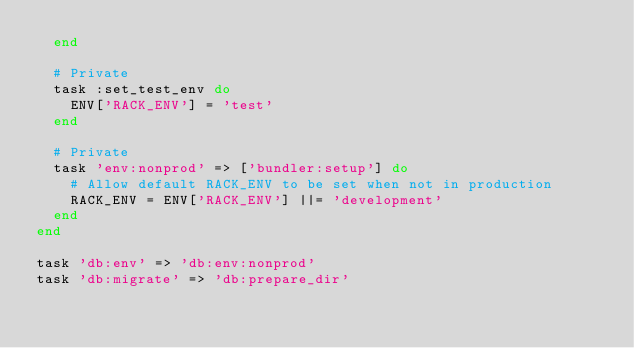<code> <loc_0><loc_0><loc_500><loc_500><_Ruby_>  end

  # Private
  task :set_test_env do
    ENV['RACK_ENV'] = 'test'
  end

  # Private
  task 'env:nonprod' => ['bundler:setup'] do
    # Allow default RACK_ENV to be set when not in production
    RACK_ENV = ENV['RACK_ENV'] ||= 'development'
  end
end

task 'db:env' => 'db:env:nonprod'
task 'db:migrate' => 'db:prepare_dir'
</code> 